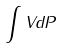<formula> <loc_0><loc_0><loc_500><loc_500>\int V d P</formula> 